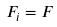<formula> <loc_0><loc_0><loc_500><loc_500>F _ { i } = F</formula> 